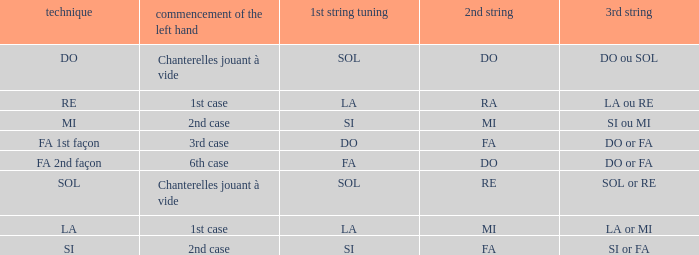What is the left-hand start for the 2nd string of ra? 1st case. 